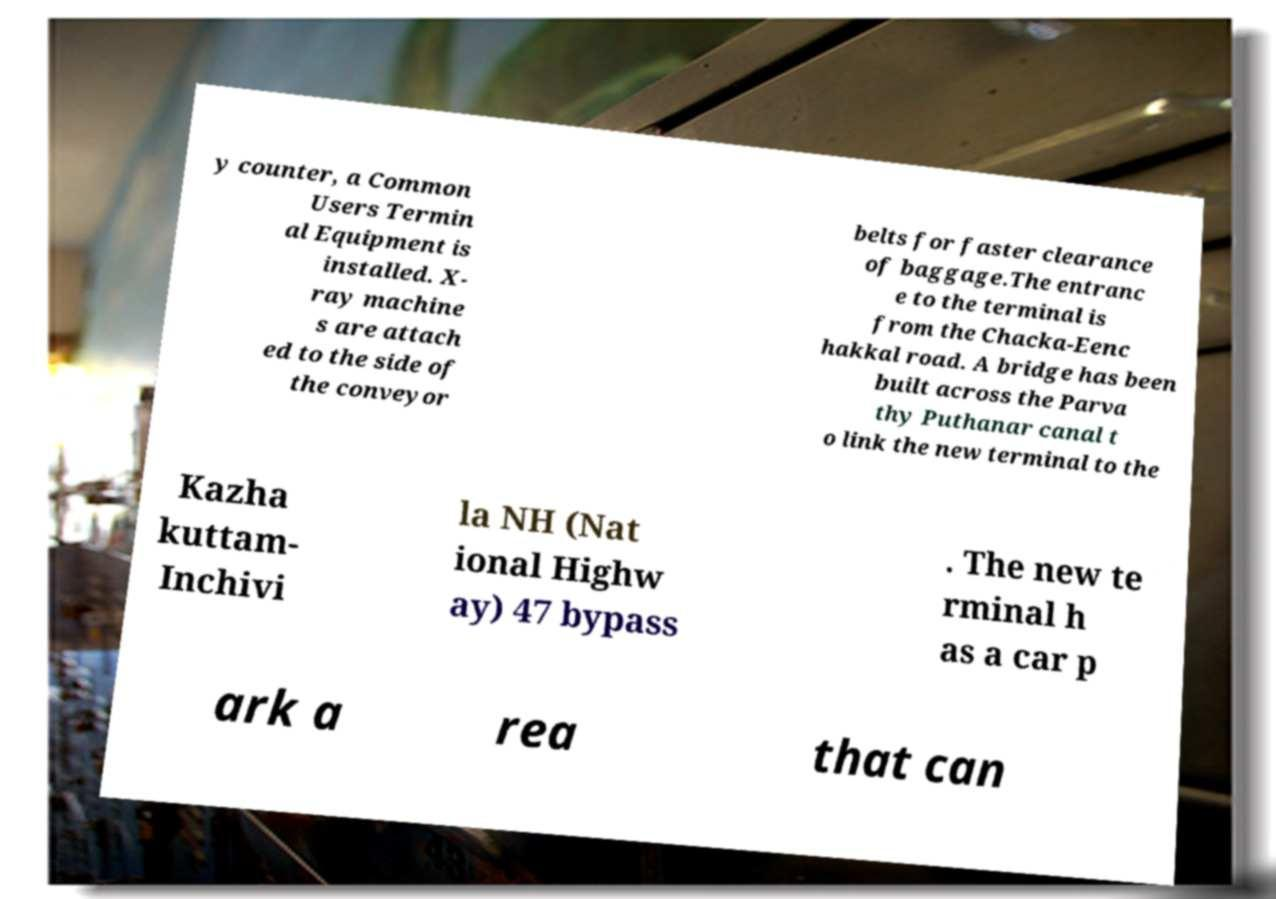Can you accurately transcribe the text from the provided image for me? y counter, a Common Users Termin al Equipment is installed. X- ray machine s are attach ed to the side of the conveyor belts for faster clearance of baggage.The entranc e to the terminal is from the Chacka-Eenc hakkal road. A bridge has been built across the Parva thy Puthanar canal t o link the new terminal to the Kazha kuttam- Inchivi la NH (Nat ional Highw ay) 47 bypass . The new te rminal h as a car p ark a rea that can 